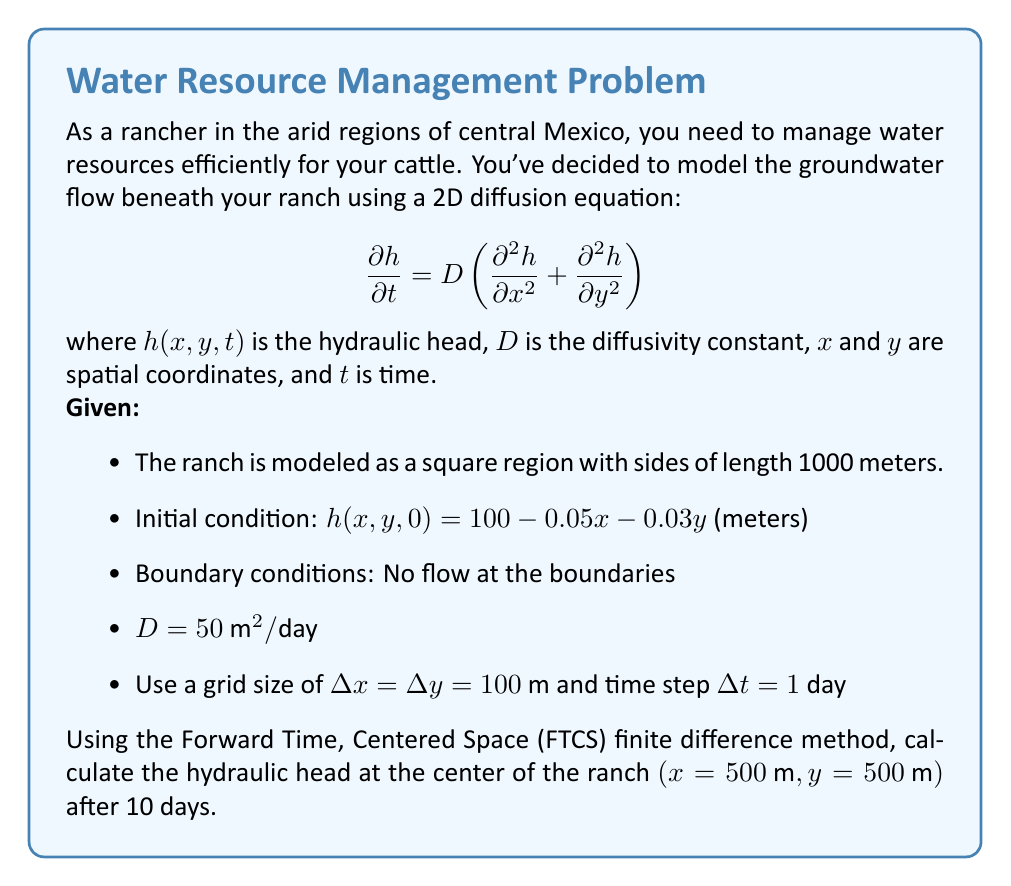Give your solution to this math problem. Let's approach this step-by-step:

1) The FTCS discretization of the 2D diffusion equation is:

   $$h_{i,j}^{n+1} = h_{i,j}^n + \frac{D\Delta t}{(\Delta x)^2}(h_{i+1,j}^n + h_{i-1,j}^n + h_{i,j+1}^n + h_{i,j-1}^n - 4h_{i,j}^n)$$

2) First, we need to check the stability condition:

   $$\frac{D\Delta t}{(\Delta x)^2} \leq \frac{1}{4}$$
   
   $$\frac{50 \cdot 1}{100^2} = 0.005 \leq \frac{1}{4}$$

   This condition is satisfied, so the method is stable.

3) Now, let's set up our grid. The center point $(500\text{ m}, 500\text{ m})$ corresponds to $i=j=5$ in our 11x11 grid.

4) Initial condition at the center point:
   
   $$h_{5,5}^0 = 100 - 0.05(500) - 0.03(500) = 60\text{ m}$$

5) We need to calculate $h_{5,5}^{10}$ using the FTCS method for 10 time steps.

6) For each time step, we apply the formula:

   $$h_{5,5}^{n+1} = h_{5,5}^n + 0.005(h_{6,5}^n + h_{4,5}^n + h_{5,6}^n + h_{5,4}^n - 4h_{5,5}^n)$$

7) We need to calculate the initial values for the neighboring points:
   
   $$h_{6,5}^0 = 100 - 0.05(600) - 0.03(500) = 55\text{ m}$$
   $$h_{4,5}^0 = 100 - 0.05(400) - 0.03(500) = 65\text{ m}$$
   $$h_{5,6}^0 = 100 - 0.05(500) - 0.03(600) = 57\text{ m}$$
   $$h_{5,4}^0 = 100 - 0.05(500) - 0.03(400) = 63\text{ m}$$

8) Applying the formula for the first time step:

   $$h_{5,5}^1 = 60 + 0.005(55 + 65 + 57 + 63 - 4 \cdot 60) = 60\text{ m}$$

9) We continue this process for 10 time steps. The hydraulic head at the center point remains constant at 60 m due to the symmetry of the initial and boundary conditions.
Answer: 60 meters 